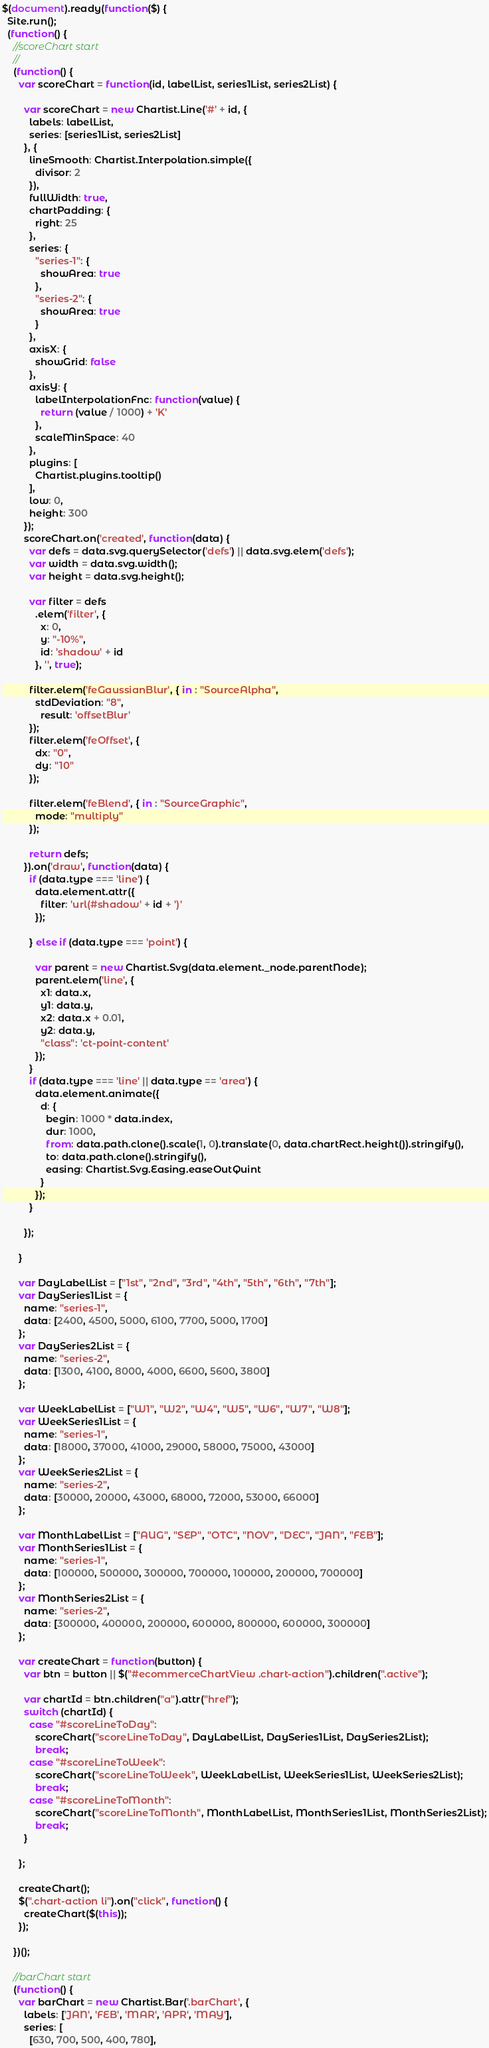<code> <loc_0><loc_0><loc_500><loc_500><_JavaScript_>$(document).ready(function($) {
  Site.run();
  (function() {
    //scoreChart start
    //
    (function() {
      var scoreChart = function(id, labelList, series1List, series2List) {

        var scoreChart = new Chartist.Line('#' + id, {
          labels: labelList,
          series: [series1List, series2List]
        }, {
          lineSmooth: Chartist.Interpolation.simple({
            divisor: 2
          }),
          fullWidth: true,
          chartPadding: {
            right: 25
          },
          series: {
            "series-1": {
              showArea: true
            },
            "series-2": {
              showArea: true
            }
          },
          axisX: {
            showGrid: false
          },
          axisY: {
            labelInterpolationFnc: function(value) {
              return (value / 1000) + 'K'
            },
            scaleMinSpace: 40
          },
          plugins: [
            Chartist.plugins.tooltip()
          ],
          low: 0,
          height: 300
        });
        scoreChart.on('created', function(data) {
          var defs = data.svg.querySelector('defs') || data.svg.elem('defs');
          var width = data.svg.width();
          var height = data.svg.height();

          var filter = defs
            .elem('filter', {
              x: 0,
              y: "-10%",
              id: 'shadow' + id
            }, '', true);

          filter.elem('feGaussianBlur', { in : "SourceAlpha",
            stdDeviation: "8",
              result: 'offsetBlur'
          });
          filter.elem('feOffset', {
            dx: "0",
            dy: "10"
          });

          filter.elem('feBlend', { in : "SourceGraphic",
            mode: "multiply"
          });

          return defs;
        }).on('draw', function(data) {
          if (data.type === 'line') {
            data.element.attr({
              filter: 'url(#shadow' + id + ')'
            });

          } else if (data.type === 'point') {

            var parent = new Chartist.Svg(data.element._node.parentNode);
            parent.elem('line', {
              x1: data.x,
              y1: data.y,
              x2: data.x + 0.01,
              y2: data.y,
              "class": 'ct-point-content'
            });
          }
          if (data.type === 'line' || data.type == 'area') {
            data.element.animate({
              d: {
                begin: 1000 * data.index,
                dur: 1000,
                from: data.path.clone().scale(1, 0).translate(0, data.chartRect.height()).stringify(),
                to: data.path.clone().stringify(),
                easing: Chartist.Svg.Easing.easeOutQuint
              }
            });
          }

        });

      }

      var DayLabelList = ["1st", "2nd", "3rd", "4th", "5th", "6th", "7th"];
      var DaySeries1List = {
        name: "series-1",
        data: [2400, 4500, 5000, 6100, 7700, 5000, 1700]
      };
      var DaySeries2List = {
        name: "series-2",
        data: [1300, 4100, 8000, 4000, 6600, 5600, 3800]
      };

      var WeekLabelList = ["W1", "W2", "W4", "W5", "W6", "W7", "W8"];
      var WeekSeries1List = {
        name: "series-1",
        data: [18000, 37000, 41000, 29000, 58000, 75000, 43000]
      };
      var WeekSeries2List = {
        name: "series-2",
        data: [30000, 20000, 43000, 68000, 72000, 53000, 66000]
      };

      var MonthLabelList = ["AUG", "SEP", "OTC", "NOV", "DEC", "JAN", "FEB"];
      var MonthSeries1List = {
        name: "series-1",
        data: [100000, 500000, 300000, 700000, 100000, 200000, 700000]
      };
      var MonthSeries2List = {
        name: "series-2",
        data: [300000, 400000, 200000, 600000, 800000, 600000, 300000]
      };

      var createChart = function(button) {
        var btn = button || $("#ecommerceChartView .chart-action").children(".active");

        var chartId = btn.children("a").attr("href");
        switch (chartId) {
          case "#scoreLineToDay":
            scoreChart("scoreLineToDay", DayLabelList, DaySeries1List, DaySeries2List);
            break;
          case "#scoreLineToWeek":
            scoreChart("scoreLineToWeek", WeekLabelList, WeekSeries1List, WeekSeries2List);
            break;
          case "#scoreLineToMonth":
            scoreChart("scoreLineToMonth", MonthLabelList, MonthSeries1List, MonthSeries2List);
            break;
        }

      };

      createChart();
      $(".chart-action li").on("click", function() {
        createChart($(this));
      });

    })();

    //barChart start
    (function() {
      var barChart = new Chartist.Bar('.barChart', {
        labels: ['JAN', 'FEB', 'MAR', 'APR', 'MAY'],
        series: [
          [630, 700, 500, 400, 780],</code> 